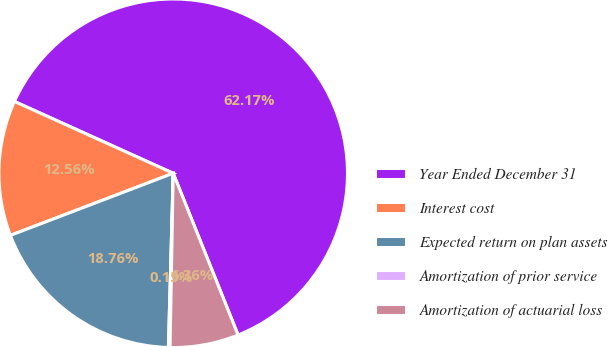<chart> <loc_0><loc_0><loc_500><loc_500><pie_chart><fcel>Year Ended December 31<fcel>Interest cost<fcel>Expected return on plan assets<fcel>Amortization of prior service<fcel>Amortization of actuarial loss<nl><fcel>62.17%<fcel>12.56%<fcel>18.76%<fcel>0.15%<fcel>6.36%<nl></chart> 